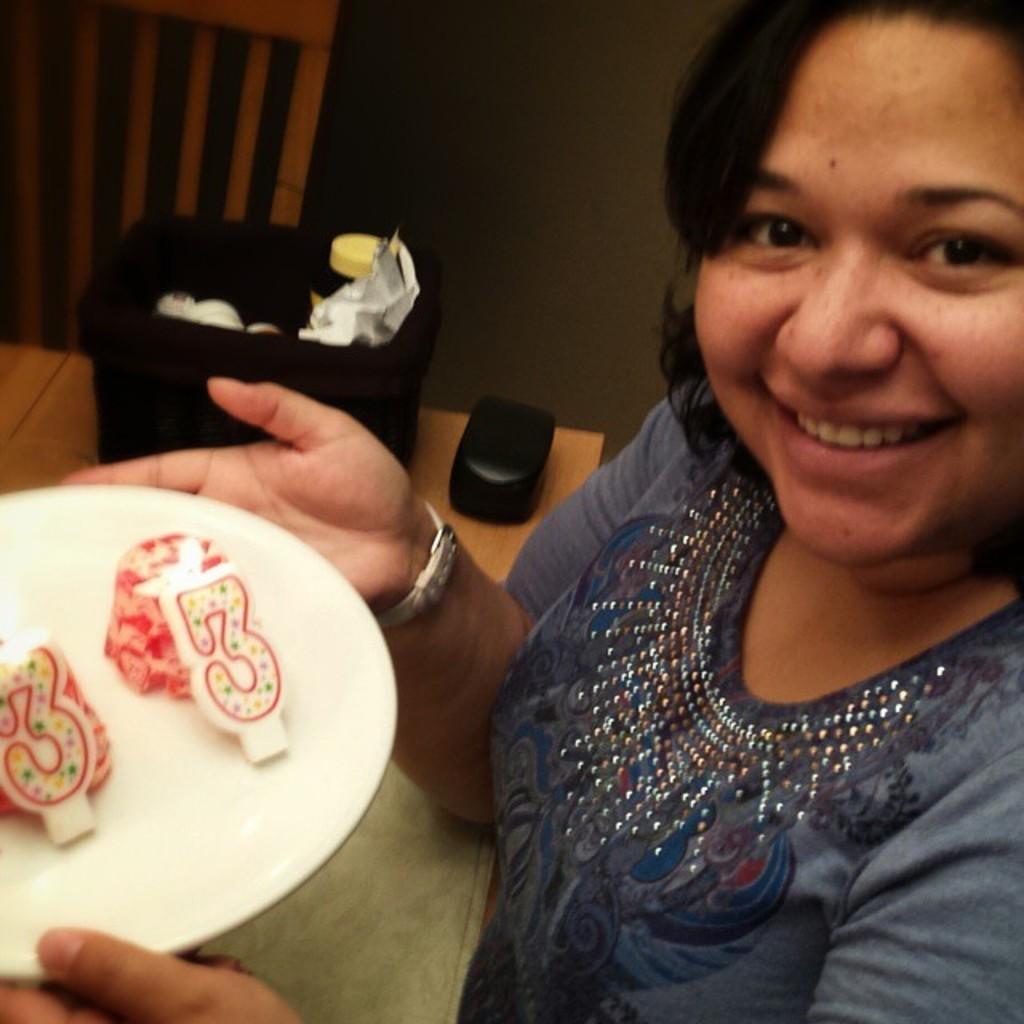Describe this image in one or two sentences. In this image, I can see a woman smiling and holding a plate with candles. I can see a box, objects in a basket and a cloth on a table. In the top left side of the image, it looks like a chair. In the background there is a wall. 